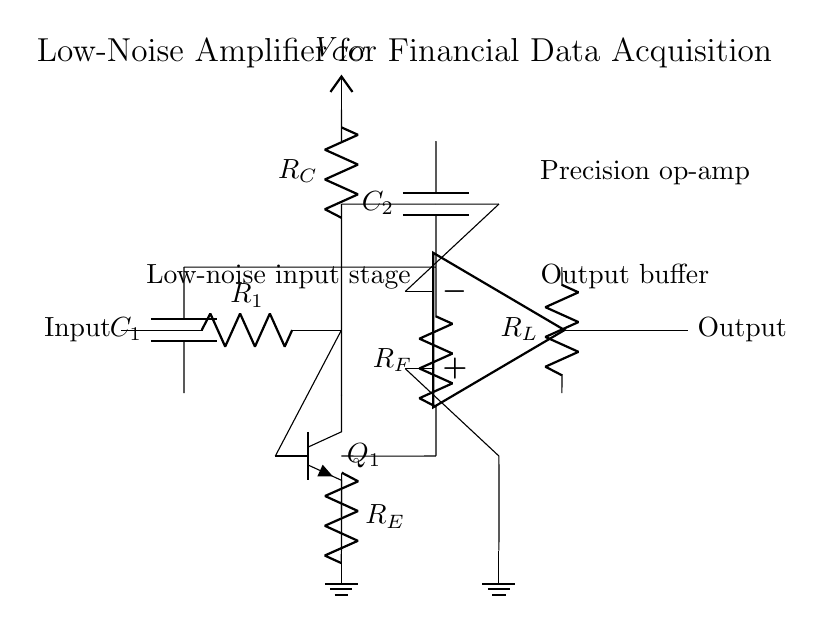What is the role of the capacitor C1? The capacitor C1 is used for coupling the input signal while blocking any DC component, allowing only the AC variations to reach the amplifier.
Answer: Coupling What type of transistor is used in the circuit? The circuit uses an npn transistor (Q1) to amplify the input signal, providing increased current gain.
Answer: npn What is the purpose of the feedback resistor R_F? The feedback resistor R_F stabilizes the gain of the amplifier by providing a portion of the output back to the input base, thus controlling the overall amplification and frequency response.
Answer: Stabilize gain What are the two main stages of amplification in this circuit? The two main stages consist of the transistor stage with Q1 and the operational amplifier stage, which work together to amplify the input signal.
Answer: Transistor and op-amp stages What is the power supply voltage value denoted in the circuit? The power supply voltage is designated as V_CC, which indicates the voltage level provided to power the amplifier's active components.
Answer: V_CC What does the label "Low-noise input stage" indicate? The label indicates that this part of the circuit is designed to minimize the introduction of noise into the signal being amplified, which is critical for precise financial data acquisition.
Answer: Minimize noise What is the function of the output buffer in this circuit? The output buffer serves to provide increased output current capability and isolates the load from the previous stages, preventing loading effects that may influence the performance of the amplifier.
Answer: Provide isolation 